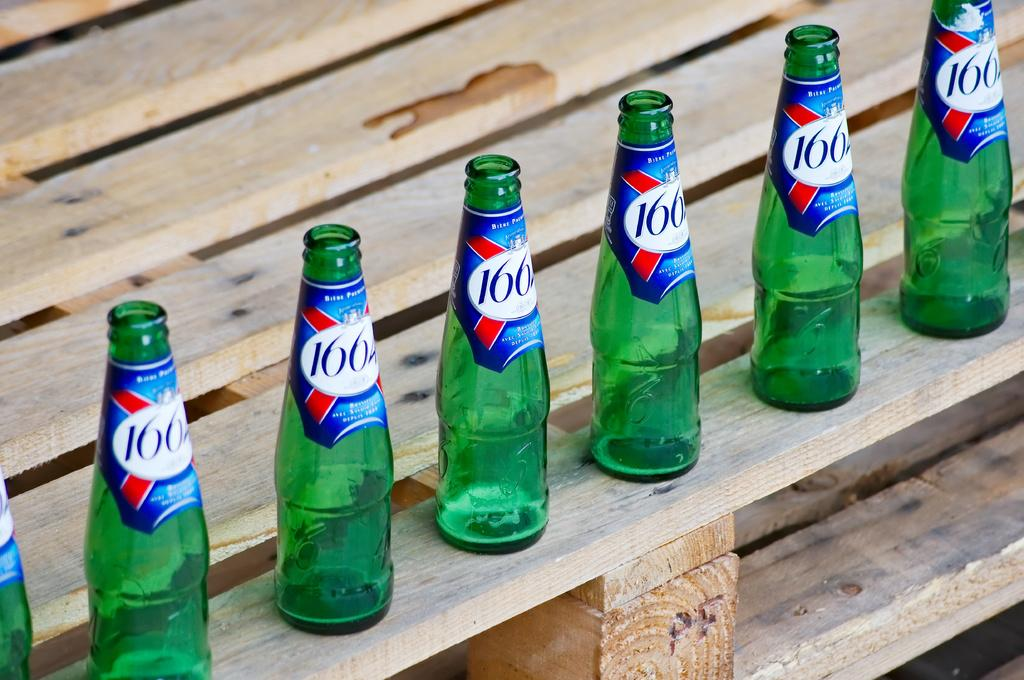<image>
Give a short and clear explanation of the subsequent image. many empty green bottles of a drink labeled 1664 